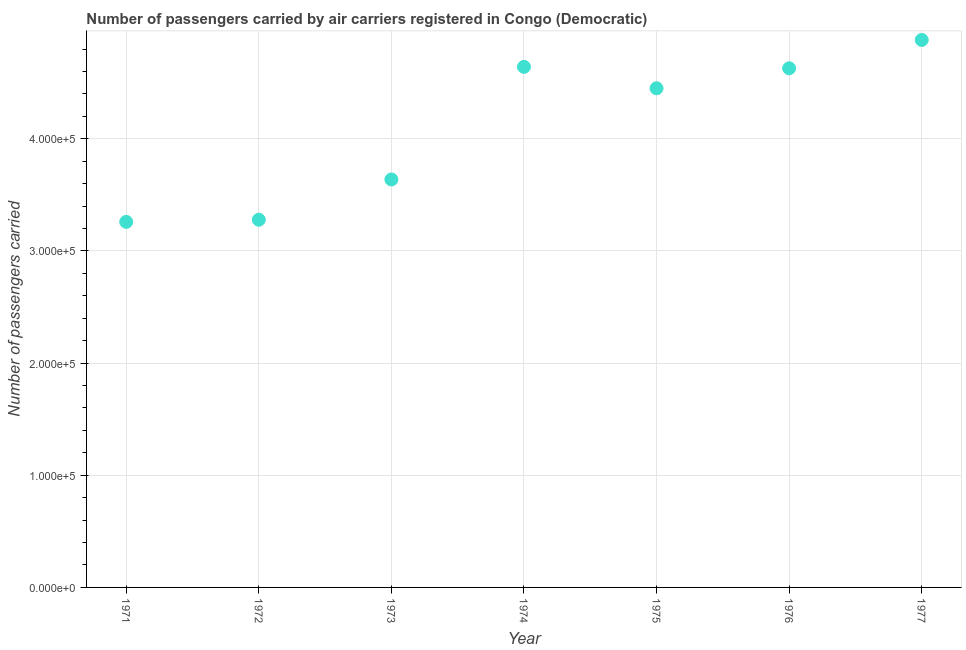What is the number of passengers carried in 1971?
Your answer should be compact. 3.26e+05. Across all years, what is the maximum number of passengers carried?
Ensure brevity in your answer.  4.88e+05. Across all years, what is the minimum number of passengers carried?
Offer a terse response. 3.26e+05. In which year was the number of passengers carried minimum?
Your answer should be very brief. 1971. What is the sum of the number of passengers carried?
Offer a very short reply. 2.88e+06. What is the difference between the number of passengers carried in 1973 and 1975?
Keep it short and to the point. -8.13e+04. What is the average number of passengers carried per year?
Your answer should be compact. 4.11e+05. What is the median number of passengers carried?
Provide a succinct answer. 4.45e+05. Do a majority of the years between 1976 and 1972 (inclusive) have number of passengers carried greater than 360000 ?
Offer a terse response. Yes. What is the ratio of the number of passengers carried in 1971 to that in 1977?
Ensure brevity in your answer.  0.67. Is the number of passengers carried in 1976 less than that in 1977?
Give a very brief answer. Yes. Is the difference between the number of passengers carried in 1972 and 1976 greater than the difference between any two years?
Make the answer very short. No. What is the difference between the highest and the second highest number of passengers carried?
Provide a succinct answer. 2.40e+04. What is the difference between the highest and the lowest number of passengers carried?
Keep it short and to the point. 1.62e+05. How many dotlines are there?
Your answer should be compact. 1. What is the difference between two consecutive major ticks on the Y-axis?
Provide a succinct answer. 1.00e+05. Does the graph contain grids?
Your response must be concise. Yes. What is the title of the graph?
Keep it short and to the point. Number of passengers carried by air carriers registered in Congo (Democratic). What is the label or title of the Y-axis?
Offer a very short reply. Number of passengers carried. What is the Number of passengers carried in 1971?
Make the answer very short. 3.26e+05. What is the Number of passengers carried in 1972?
Your answer should be compact. 3.28e+05. What is the Number of passengers carried in 1973?
Provide a short and direct response. 3.64e+05. What is the Number of passengers carried in 1974?
Keep it short and to the point. 4.64e+05. What is the Number of passengers carried in 1975?
Offer a terse response. 4.45e+05. What is the Number of passengers carried in 1976?
Offer a terse response. 4.63e+05. What is the Number of passengers carried in 1977?
Your answer should be compact. 4.88e+05. What is the difference between the Number of passengers carried in 1971 and 1972?
Offer a terse response. -1900. What is the difference between the Number of passengers carried in 1971 and 1973?
Give a very brief answer. -3.78e+04. What is the difference between the Number of passengers carried in 1971 and 1974?
Keep it short and to the point. -1.38e+05. What is the difference between the Number of passengers carried in 1971 and 1975?
Provide a succinct answer. -1.19e+05. What is the difference between the Number of passengers carried in 1971 and 1976?
Ensure brevity in your answer.  -1.37e+05. What is the difference between the Number of passengers carried in 1971 and 1977?
Your answer should be compact. -1.62e+05. What is the difference between the Number of passengers carried in 1972 and 1973?
Provide a short and direct response. -3.59e+04. What is the difference between the Number of passengers carried in 1972 and 1974?
Offer a very short reply. -1.36e+05. What is the difference between the Number of passengers carried in 1972 and 1975?
Keep it short and to the point. -1.17e+05. What is the difference between the Number of passengers carried in 1972 and 1976?
Your response must be concise. -1.35e+05. What is the difference between the Number of passengers carried in 1972 and 1977?
Your answer should be very brief. -1.60e+05. What is the difference between the Number of passengers carried in 1973 and 1974?
Your response must be concise. -1.00e+05. What is the difference between the Number of passengers carried in 1973 and 1975?
Provide a succinct answer. -8.13e+04. What is the difference between the Number of passengers carried in 1973 and 1976?
Offer a very short reply. -9.91e+04. What is the difference between the Number of passengers carried in 1973 and 1977?
Give a very brief answer. -1.24e+05. What is the difference between the Number of passengers carried in 1974 and 1975?
Your response must be concise. 1.91e+04. What is the difference between the Number of passengers carried in 1974 and 1976?
Your answer should be compact. 1300. What is the difference between the Number of passengers carried in 1974 and 1977?
Offer a terse response. -2.40e+04. What is the difference between the Number of passengers carried in 1975 and 1976?
Make the answer very short. -1.78e+04. What is the difference between the Number of passengers carried in 1975 and 1977?
Provide a short and direct response. -4.31e+04. What is the difference between the Number of passengers carried in 1976 and 1977?
Ensure brevity in your answer.  -2.53e+04. What is the ratio of the Number of passengers carried in 1971 to that in 1973?
Keep it short and to the point. 0.9. What is the ratio of the Number of passengers carried in 1971 to that in 1974?
Give a very brief answer. 0.7. What is the ratio of the Number of passengers carried in 1971 to that in 1975?
Provide a succinct answer. 0.73. What is the ratio of the Number of passengers carried in 1971 to that in 1976?
Your response must be concise. 0.7. What is the ratio of the Number of passengers carried in 1971 to that in 1977?
Your response must be concise. 0.67. What is the ratio of the Number of passengers carried in 1972 to that in 1973?
Provide a short and direct response. 0.9. What is the ratio of the Number of passengers carried in 1972 to that in 1974?
Provide a succinct answer. 0.71. What is the ratio of the Number of passengers carried in 1972 to that in 1975?
Offer a very short reply. 0.74. What is the ratio of the Number of passengers carried in 1972 to that in 1976?
Offer a very short reply. 0.71. What is the ratio of the Number of passengers carried in 1972 to that in 1977?
Ensure brevity in your answer.  0.67. What is the ratio of the Number of passengers carried in 1973 to that in 1974?
Provide a succinct answer. 0.78. What is the ratio of the Number of passengers carried in 1973 to that in 1975?
Ensure brevity in your answer.  0.82. What is the ratio of the Number of passengers carried in 1973 to that in 1976?
Provide a succinct answer. 0.79. What is the ratio of the Number of passengers carried in 1973 to that in 1977?
Provide a short and direct response. 0.74. What is the ratio of the Number of passengers carried in 1974 to that in 1975?
Provide a short and direct response. 1.04. What is the ratio of the Number of passengers carried in 1974 to that in 1976?
Offer a terse response. 1. What is the ratio of the Number of passengers carried in 1974 to that in 1977?
Offer a very short reply. 0.95. What is the ratio of the Number of passengers carried in 1975 to that in 1977?
Make the answer very short. 0.91. What is the ratio of the Number of passengers carried in 1976 to that in 1977?
Your response must be concise. 0.95. 